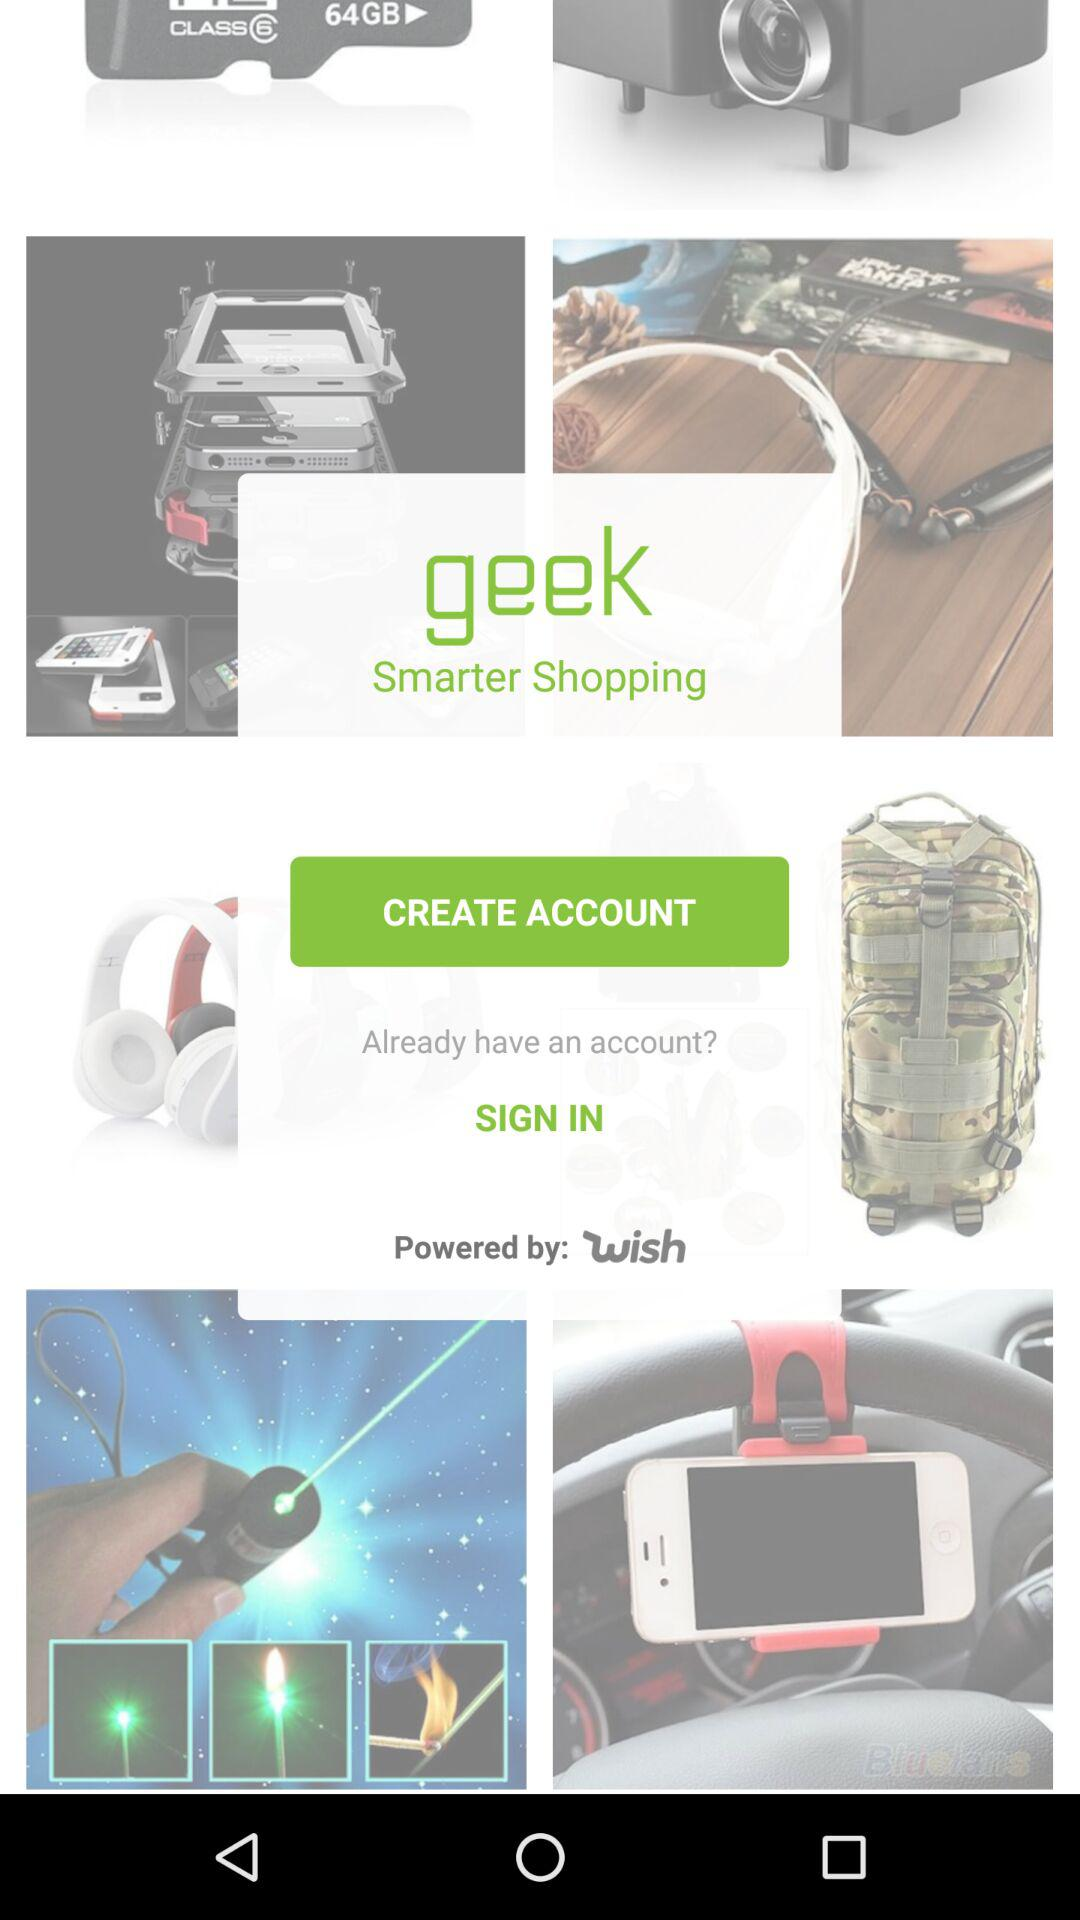What is the name of the application? The name of the application is "geek Smarter Shopping". 